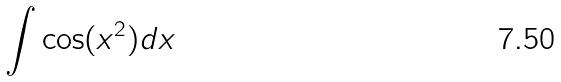<formula> <loc_0><loc_0><loc_500><loc_500>\int \cos ( x ^ { 2 } ) d x</formula> 